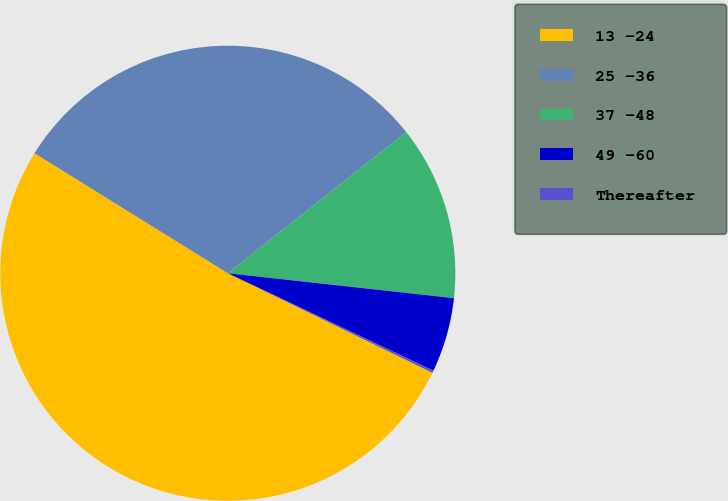<chart> <loc_0><loc_0><loc_500><loc_500><pie_chart><fcel>13 -24<fcel>25 -36<fcel>37 -48<fcel>49 -60<fcel>Thereafter<nl><fcel>51.64%<fcel>30.5%<fcel>12.4%<fcel>5.3%<fcel>0.16%<nl></chart> 